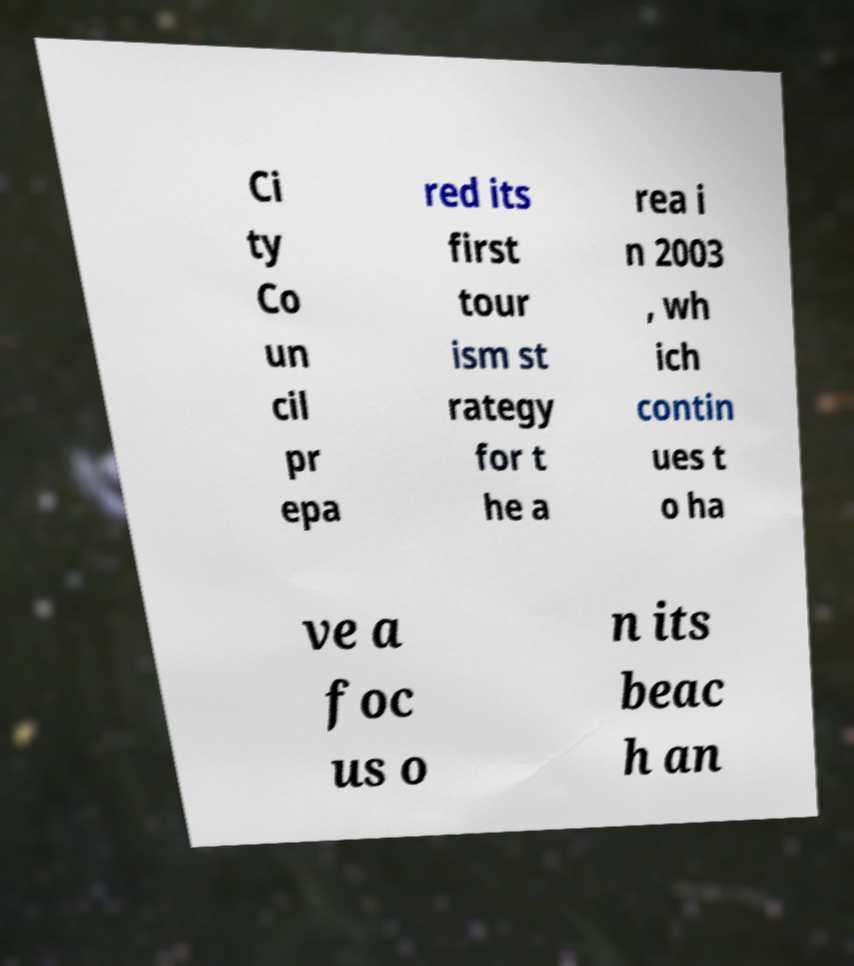For documentation purposes, I need the text within this image transcribed. Could you provide that? Ci ty Co un cil pr epa red its first tour ism st rategy for t he a rea i n 2003 , wh ich contin ues t o ha ve a foc us o n its beac h an 